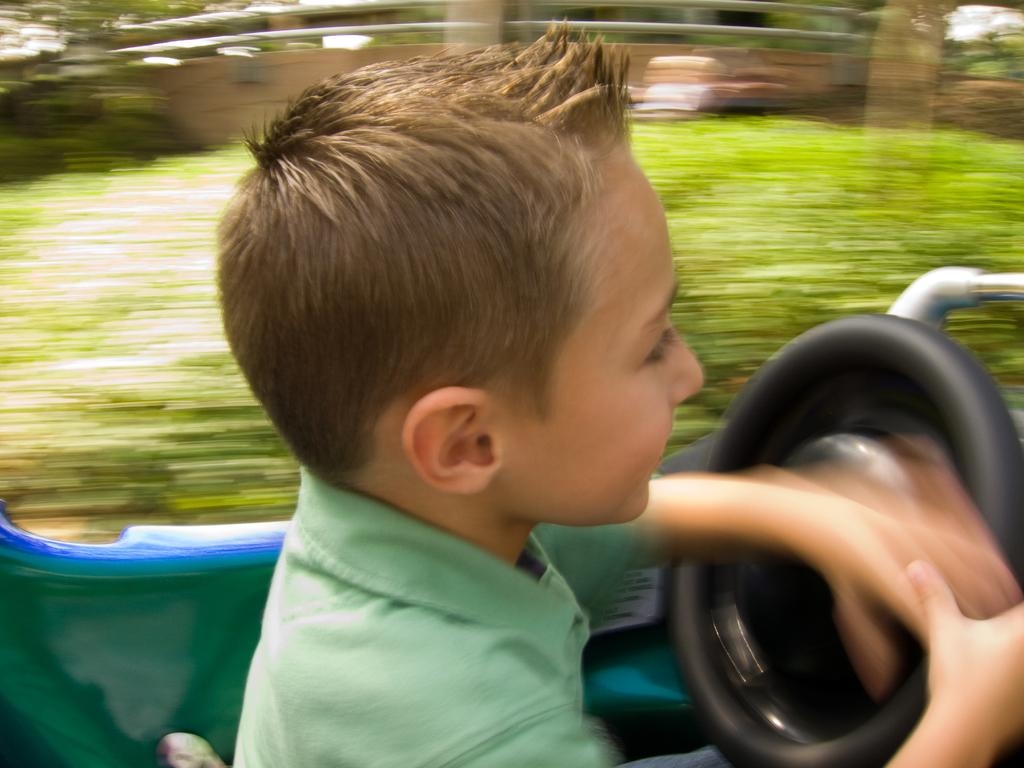Who is the main subject in the image? There is a boy in the image. What is the boy doing in the image? The boy is sitting on a vehicle and holding the steering. Can you describe the background of the image? The background of the image is blurry. Is there a servant helping the boy in the image? There is no servant present in the image. Is it raining in the image? There is no indication of rain in the image. 